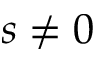Convert formula to latex. <formula><loc_0><loc_0><loc_500><loc_500>s \neq 0</formula> 